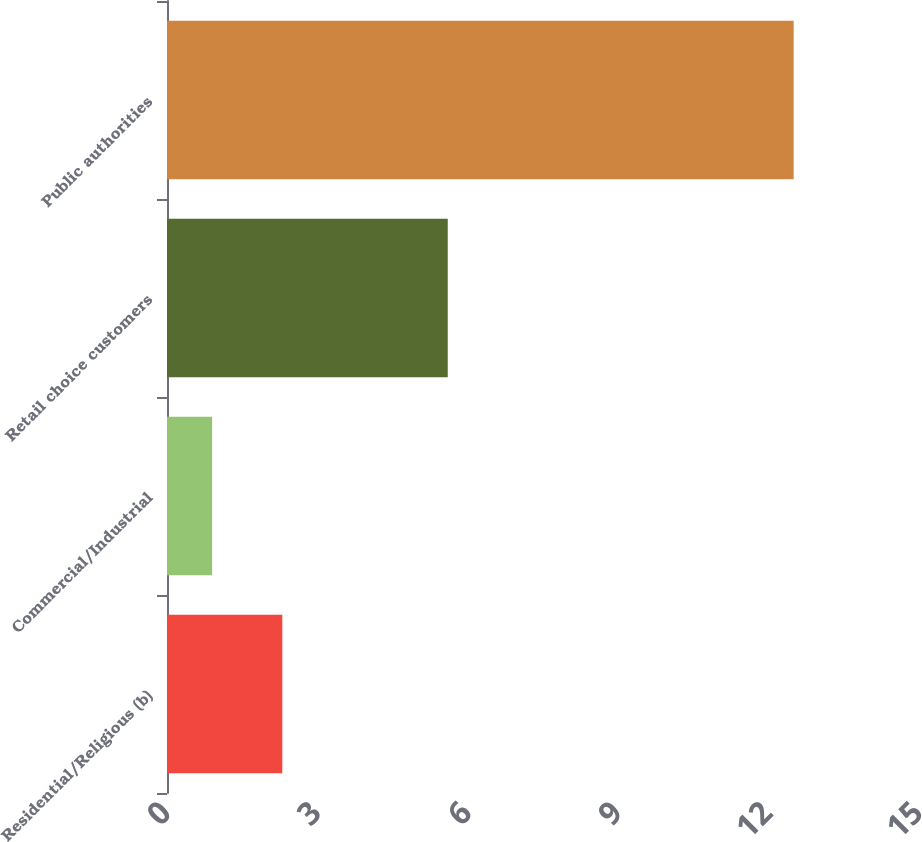<chart> <loc_0><loc_0><loc_500><loc_500><bar_chart><fcel>Residential/Religious (b)<fcel>Commercial/Industrial<fcel>Retail choice customers<fcel>Public authorities<nl><fcel>2.3<fcel>0.9<fcel>5.6<fcel>12.5<nl></chart> 